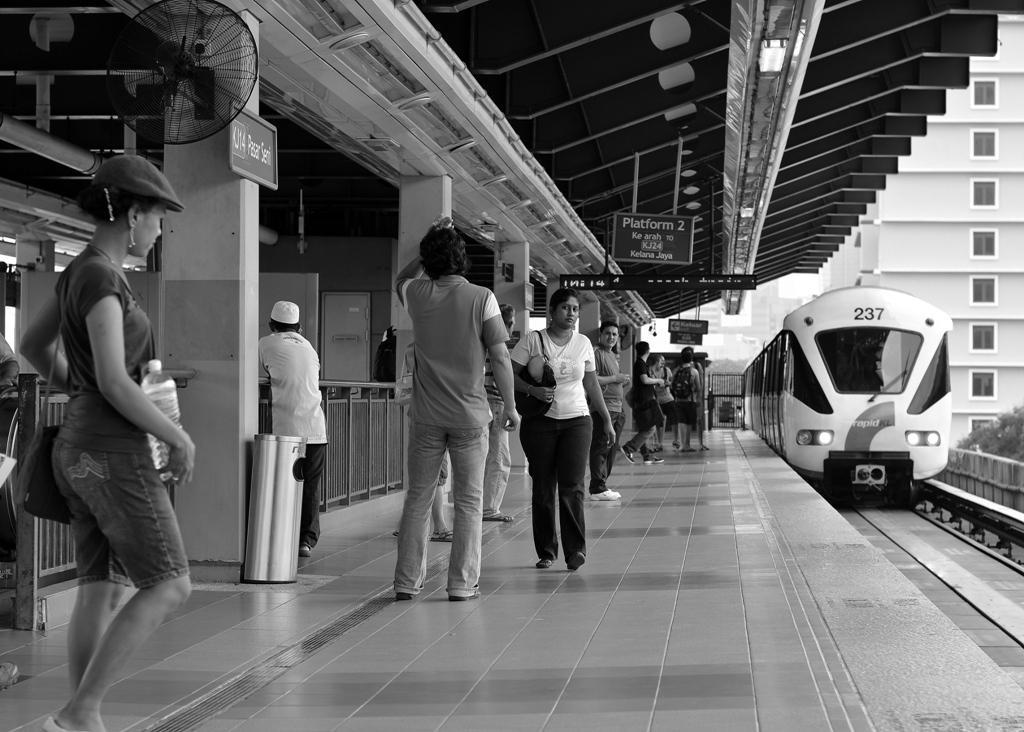How would you summarize this image in a sentence or two? This is a black and white image where we can see these people are standing on the platform, we can see dustbin, fence, fan fixed to the wall, boards, ceiling lights, a train moving on the railway track, trees and the buildings in the background. 